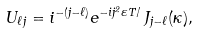<formula> <loc_0><loc_0><loc_500><loc_500>U _ { \ell j } = i ^ { - ( j - \ell ) } e ^ { - i j ^ { 2 } \varepsilon T / } \, J _ { j - \ell } ( \kappa ) ,</formula> 